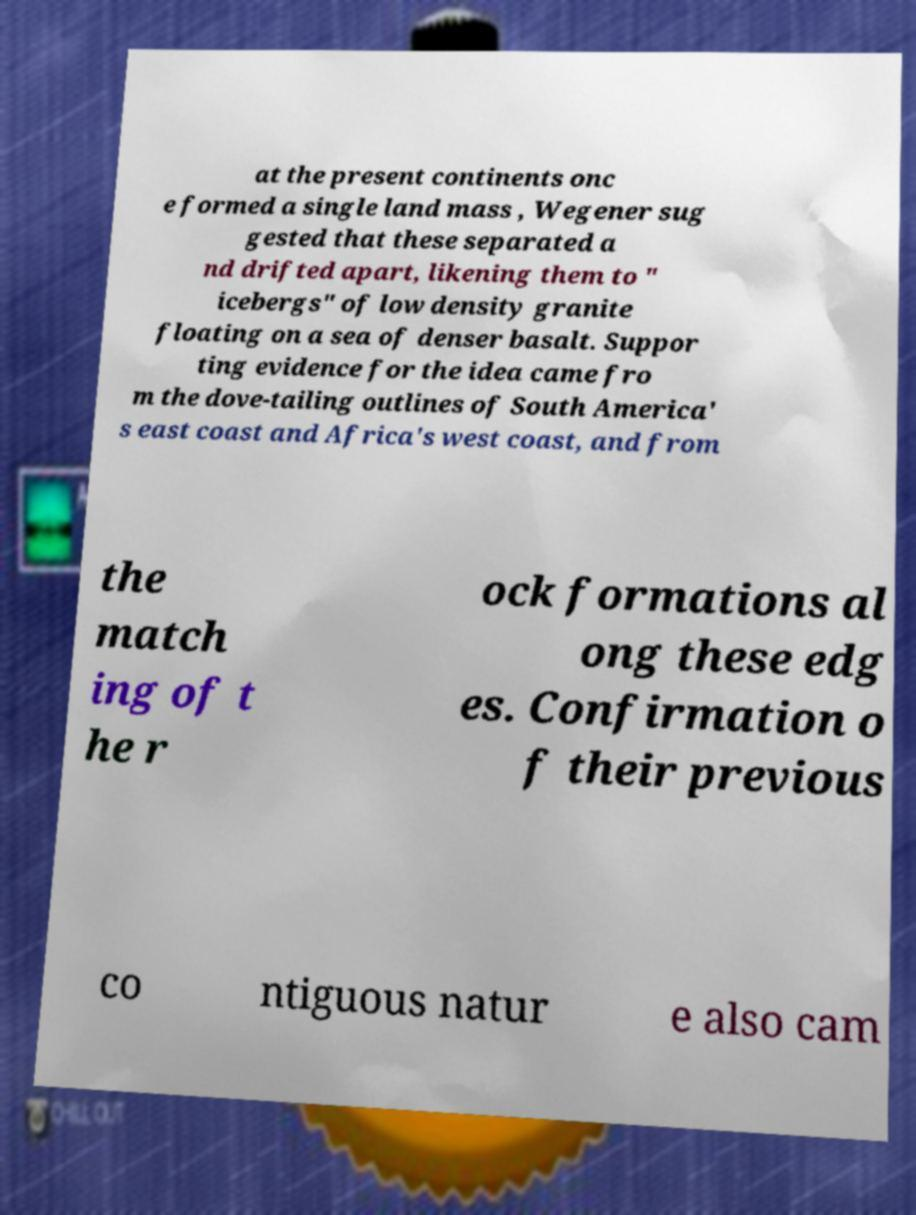For documentation purposes, I need the text within this image transcribed. Could you provide that? at the present continents onc e formed a single land mass , Wegener sug gested that these separated a nd drifted apart, likening them to " icebergs" of low density granite floating on a sea of denser basalt. Suppor ting evidence for the idea came fro m the dove-tailing outlines of South America' s east coast and Africa's west coast, and from the match ing of t he r ock formations al ong these edg es. Confirmation o f their previous co ntiguous natur e also cam 